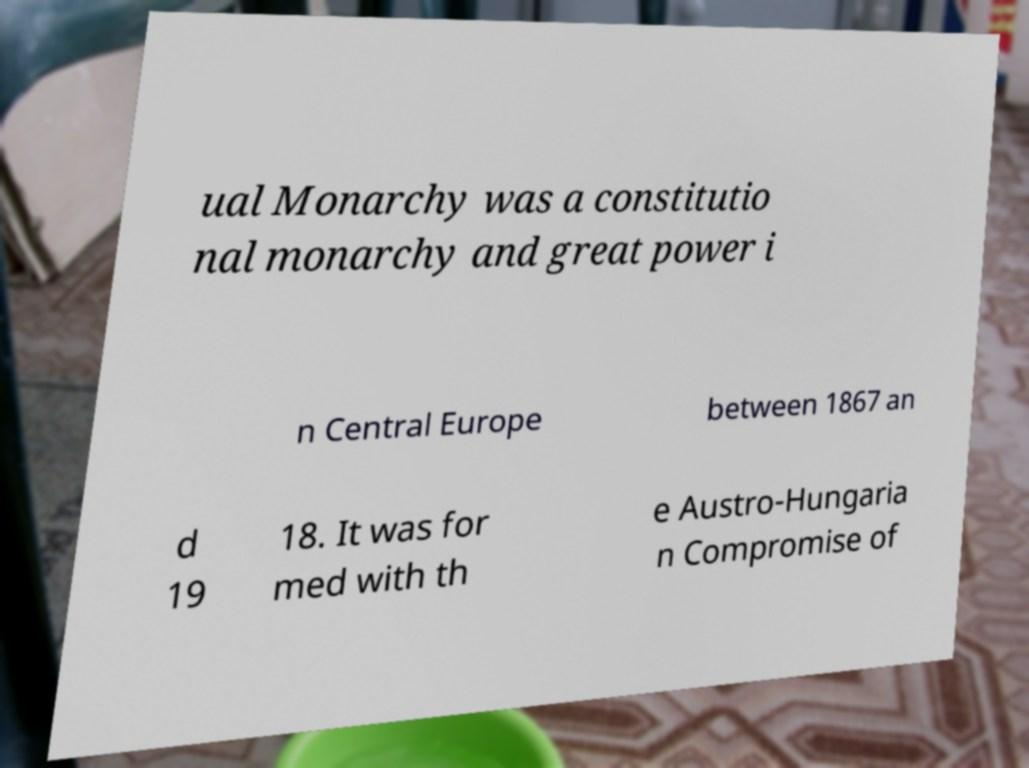Could you extract and type out the text from this image? ual Monarchy was a constitutio nal monarchy and great power i n Central Europe between 1867 an d 19 18. It was for med with th e Austro-Hungaria n Compromise of 